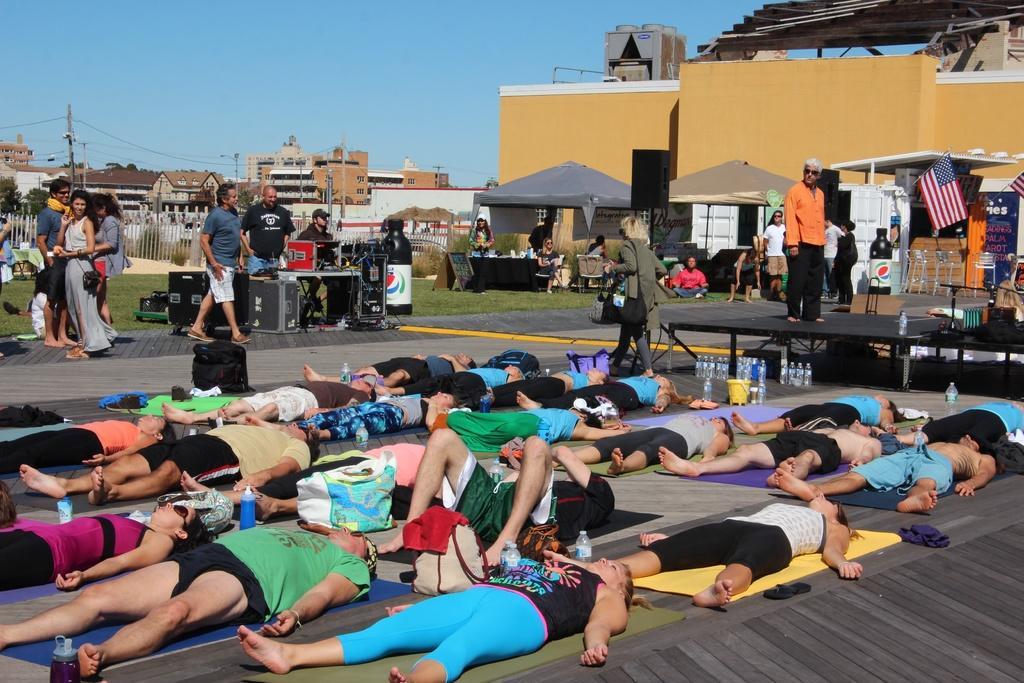How would you summarize this image in a sentence or two? In this image we can see many people lying on mars. There are bottles and bags. Also there are many people standing. And there are few people walking. And there is a platform. On that there is a person standing. In the back there are buildings and tents. Also there are flags. And we can see some boxes. Also there is railing. And there are electric poles with wires and there is sky. 